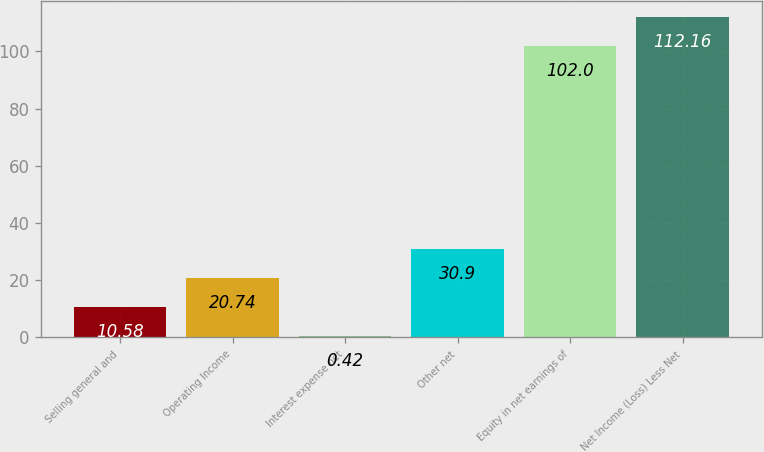Convert chart to OTSL. <chart><loc_0><loc_0><loc_500><loc_500><bar_chart><fcel>Selling general and<fcel>Operating Income<fcel>Interest expense net<fcel>Other net<fcel>Equity in net earnings of<fcel>Net Income (Loss) Less Net<nl><fcel>10.58<fcel>20.74<fcel>0.42<fcel>30.9<fcel>102<fcel>112.16<nl></chart> 